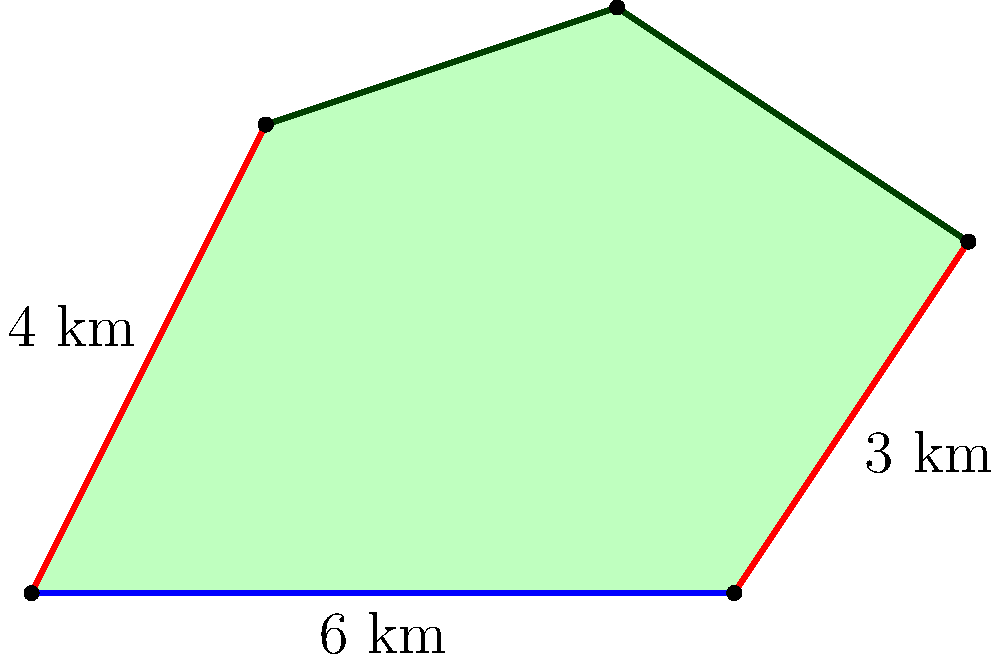As a trophy hunter, you've acquired an irregularly shaped hunting territory. To maximize your hunting efficiency, you need to calculate its area. The territory can be divided into a rectangle and two right triangles, as shown in the diagram. Given that the base of the rectangle is 6 km and the heights of the triangles are 4 km and 3 km respectively, what is the total area of your hunting grounds in square kilometers? To calculate the total area, we'll break it down into three parts:

1. Rectangle area:
   Base = 6 km, Height = 4 km
   $A_{rectangle} = 6 \times 4 = 24$ sq km

2. Left triangle area:
   Base = 2 km, Height = 4 km
   $A_{left} = \frac{1}{2} \times 2 \times 4 = 4$ sq km

3. Right triangle area:
   Base = 2 km, Height = 3 km
   $A_{right} = \frac{1}{2} \times 2 \times 3 = 3$ sq km

Total area:
$$A_{total} = A_{rectangle} + A_{left} + A_{right}$$
$$A_{total} = 24 + 4 + 3 = 31$$ sq km

Therefore, the total area of the hunting territory is 31 square kilometers.
Answer: 31 sq km 